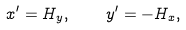Convert formula to latex. <formula><loc_0><loc_0><loc_500><loc_500>x ^ { \prime } = H _ { y } , \quad y ^ { \prime } = - H _ { x } ,</formula> 